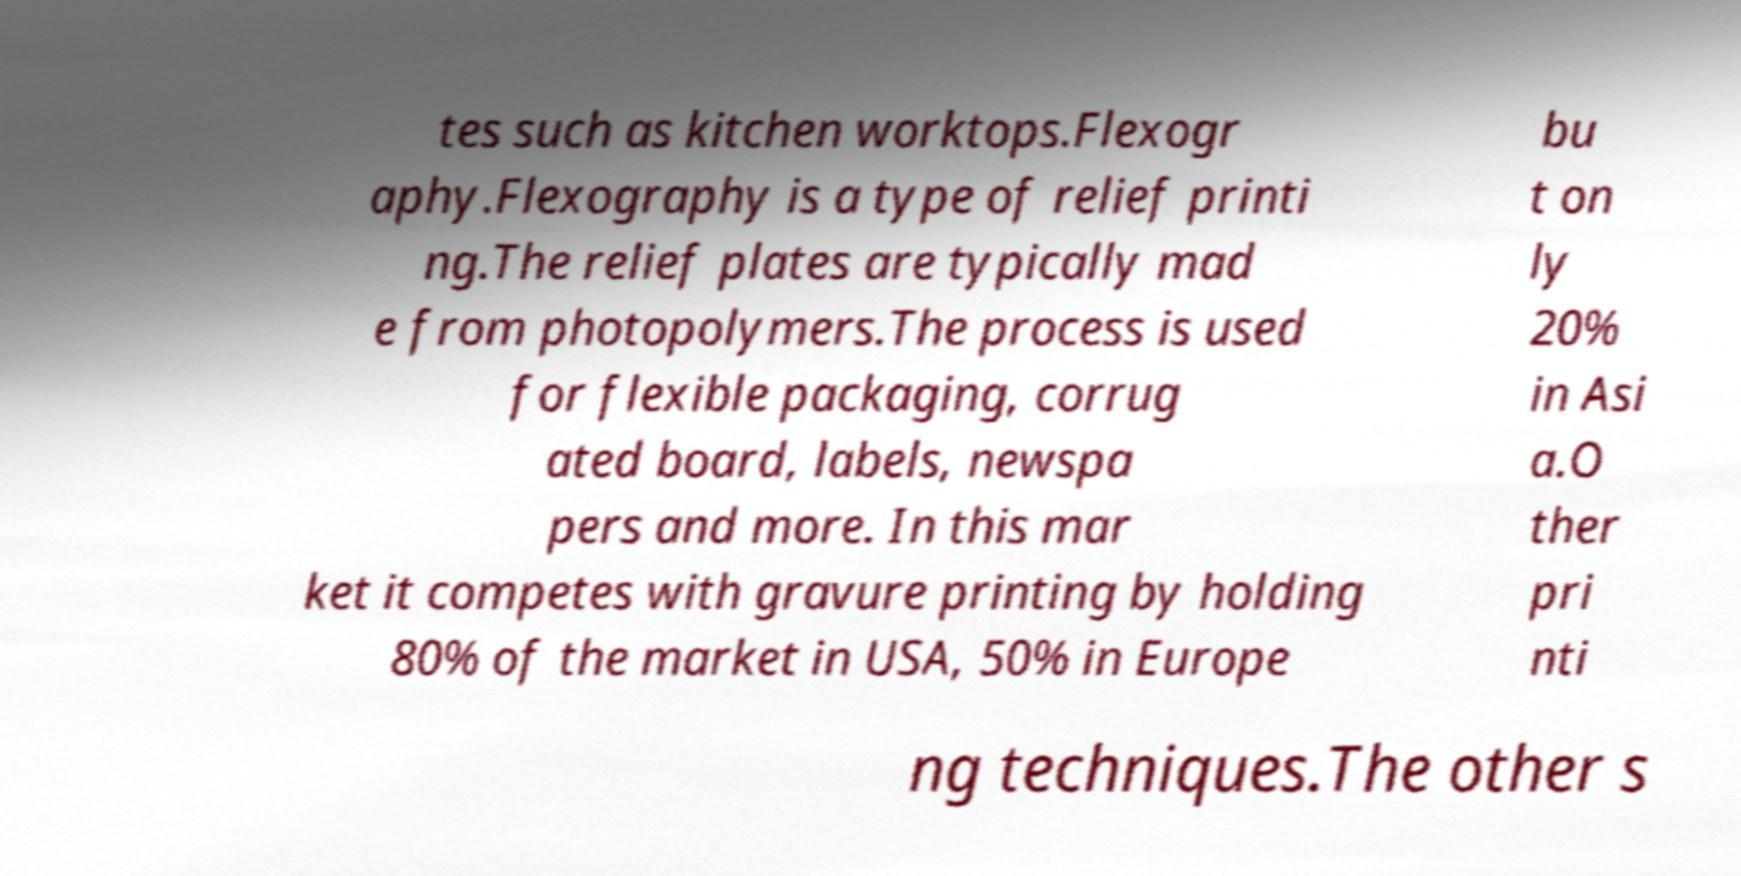Can you accurately transcribe the text from the provided image for me? tes such as kitchen worktops.Flexogr aphy.Flexography is a type of relief printi ng.The relief plates are typically mad e from photopolymers.The process is used for flexible packaging, corrug ated board, labels, newspa pers and more. In this mar ket it competes with gravure printing by holding 80% of the market in USA, 50% in Europe bu t on ly 20% in Asi a.O ther pri nti ng techniques.The other s 